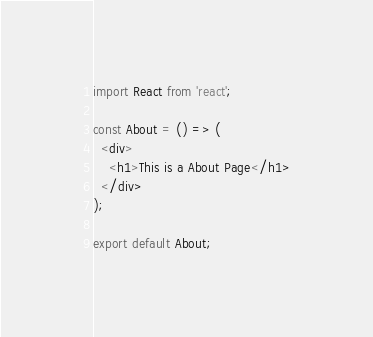Convert code to text. <code><loc_0><loc_0><loc_500><loc_500><_JavaScript_>import React from 'react';

const About = () => (
  <div>
    <h1>This is a About Page</h1>
  </div>
);

export default About;
</code> 